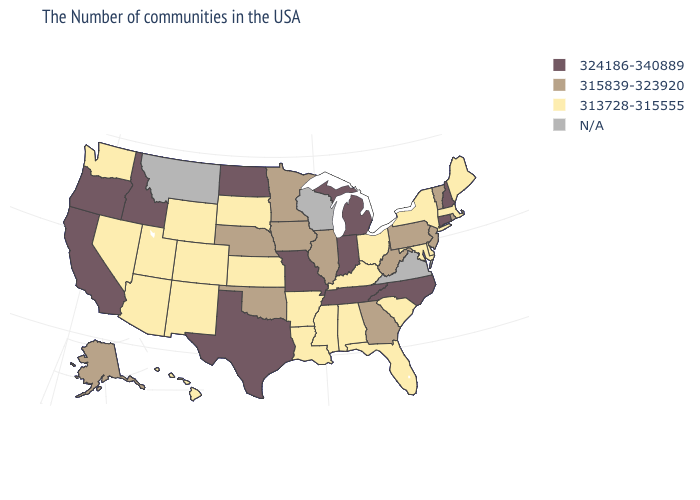Is the legend a continuous bar?
Concise answer only. No. Name the states that have a value in the range 324186-340889?
Write a very short answer. New Hampshire, Connecticut, North Carolina, Michigan, Indiana, Tennessee, Missouri, Texas, North Dakota, Idaho, California, Oregon. Name the states that have a value in the range 315839-323920?
Answer briefly. Rhode Island, Vermont, New Jersey, Pennsylvania, West Virginia, Georgia, Illinois, Minnesota, Iowa, Nebraska, Oklahoma, Alaska. What is the value of West Virginia?
Write a very short answer. 315839-323920. Does the first symbol in the legend represent the smallest category?
Keep it brief. No. What is the lowest value in the South?
Answer briefly. 313728-315555. Is the legend a continuous bar?
Answer briefly. No. What is the value of Maine?
Concise answer only. 313728-315555. What is the lowest value in the MidWest?
Give a very brief answer. 313728-315555. Does the map have missing data?
Quick response, please. Yes. What is the highest value in the USA?
Concise answer only. 324186-340889. Among the states that border New York , which have the highest value?
Concise answer only. Connecticut. Name the states that have a value in the range N/A?
Keep it brief. Virginia, Wisconsin, Montana. 